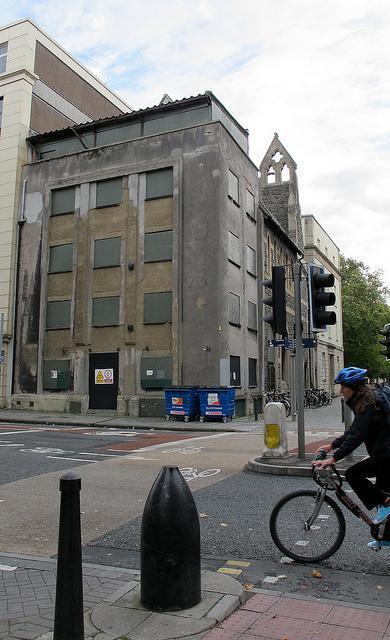How many food poles for the giraffes are there?
Give a very brief answer. 0. 